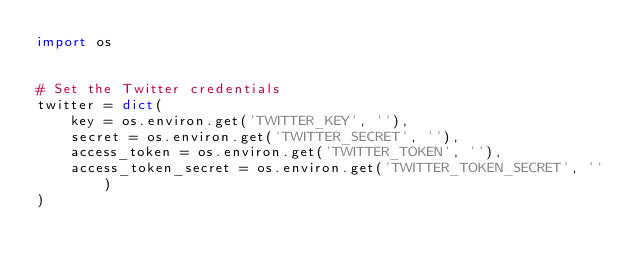Convert code to text. <code><loc_0><loc_0><loc_500><loc_500><_Python_>import os


# Set the Twitter credentials
twitter = dict(
    key = os.environ.get('TWITTER_KEY', ''),
    secret = os.environ.get('TWITTER_SECRET', ''),
    access_token = os.environ.get('TWITTER_TOKEN', ''),
    access_token_secret = os.environ.get('TWITTER_TOKEN_SECRET', '')
)
</code> 